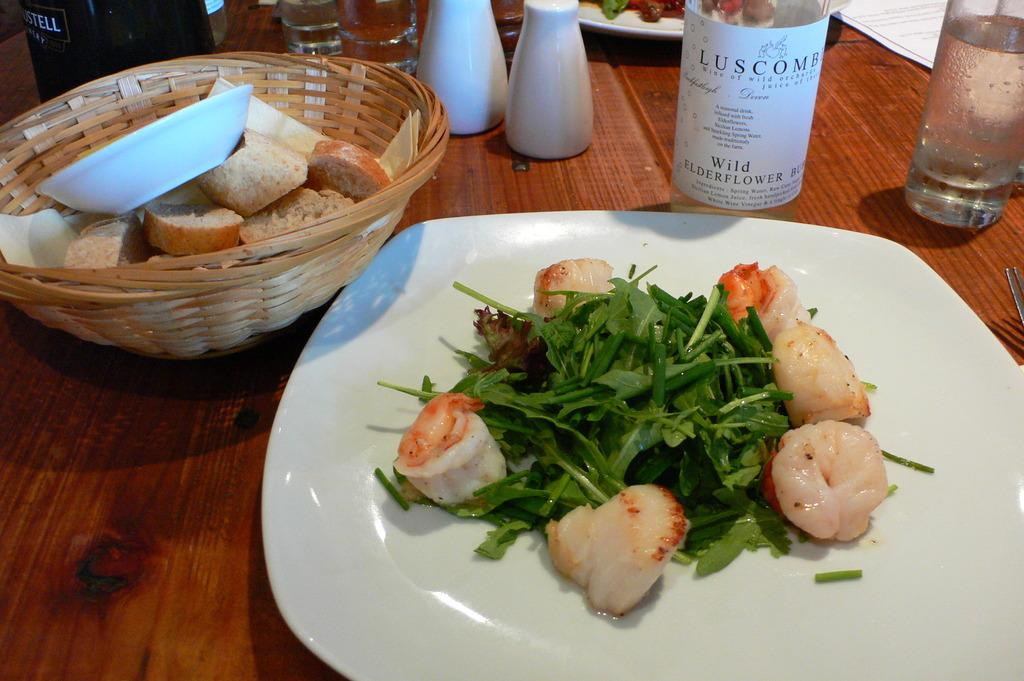What type of dishware is used for the food items in the image? There are food items on a white color plate in the image. What can be found on the left side of the image? There are bread pieces in a basket on the left side of the image. How many letters are visible on the plate in the image? There are no letters visible on the plate in the image; it contains food items. 